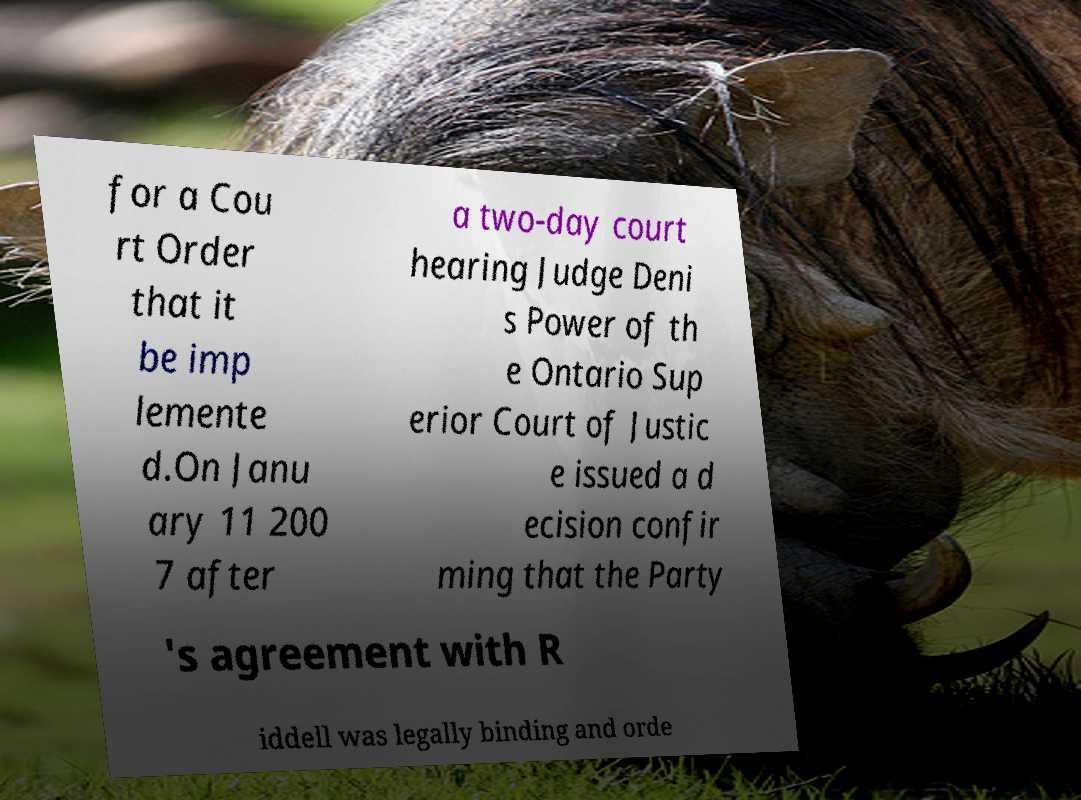Could you extract and type out the text from this image? for a Cou rt Order that it be imp lemente d.On Janu ary 11 200 7 after a two-day court hearing Judge Deni s Power of th e Ontario Sup erior Court of Justic e issued a d ecision confir ming that the Party 's agreement with R iddell was legally binding and orde 